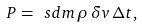<formula> <loc_0><loc_0><loc_500><loc_500>P = \ s d m \, \rho \, \delta v \, \Delta t ,</formula> 